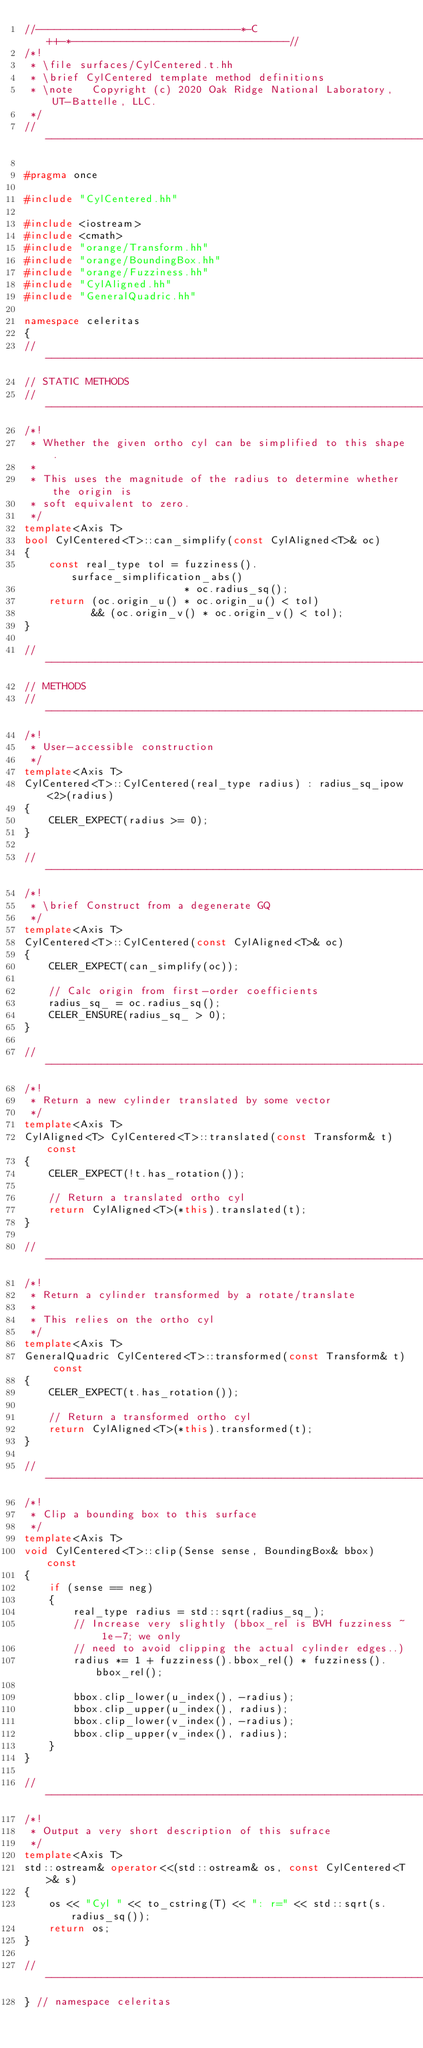<code> <loc_0><loc_0><loc_500><loc_500><_C++_>//---------------------------------*-C++-*-----------------------------------//
/*!
 * \file surfaces/CylCentered.t.hh
 * \brief CylCentered template method definitions
 * \note   Copyright (c) 2020 Oak Ridge National Laboratory, UT-Battelle, LLC.
 */
//---------------------------------------------------------------------------//

#pragma once

#include "CylCentered.hh"

#include <iostream>
#include <cmath>
#include "orange/Transform.hh"
#include "orange/BoundingBox.hh"
#include "orange/Fuzziness.hh"
#include "CylAligned.hh"
#include "GeneralQuadric.hh"

namespace celeritas
{
//---------------------------------------------------------------------------//
// STATIC METHODS
//---------------------------------------------------------------------------//
/*!
 * Whether the given ortho cyl can be simplified to this shape.
 *
 * This uses the magnitude of the radius to determine whether the origin is
 * soft equivalent to zero.
 */
template<Axis T>
bool CylCentered<T>::can_simplify(const CylAligned<T>& oc)
{
    const real_type tol = fuzziness().surface_simplification_abs()
                          * oc.radius_sq();
    return (oc.origin_u() * oc.origin_u() < tol)
           && (oc.origin_v() * oc.origin_v() < tol);
}

//---------------------------------------------------------------------------//
// METHODS
//---------------------------------------------------------------------------//
/*!
 * User-accessible construction
 */
template<Axis T>
CylCentered<T>::CylCentered(real_type radius) : radius_sq_ipow<2>(radius)
{
    CELER_EXPECT(radius >= 0);
}

//---------------------------------------------------------------------------//
/*!
 * \brief Construct from a degenerate GQ
 */
template<Axis T>
CylCentered<T>::CylCentered(const CylAligned<T>& oc)
{
    CELER_EXPECT(can_simplify(oc));

    // Calc origin from first-order coefficients
    radius_sq_ = oc.radius_sq();
    CELER_ENSURE(radius_sq_ > 0);
}

//---------------------------------------------------------------------------//
/*!
 * Return a new cylinder translated by some vector
 */
template<Axis T>
CylAligned<T> CylCentered<T>::translated(const Transform& t) const
{
    CELER_EXPECT(!t.has_rotation());

    // Return a translated ortho cyl
    return CylAligned<T>(*this).translated(t);
}

//---------------------------------------------------------------------------//
/*!
 * Return a cylinder transformed by a rotate/translate
 *
 * This relies on the ortho cyl
 */
template<Axis T>
GeneralQuadric CylCentered<T>::transformed(const Transform& t) const
{
    CELER_EXPECT(t.has_rotation());

    // Return a transformed ortho cyl
    return CylAligned<T>(*this).transformed(t);
}

//---------------------------------------------------------------------------//
/*!
 * Clip a bounding box to this surface
 */
template<Axis T>
void CylCentered<T>::clip(Sense sense, BoundingBox& bbox) const
{
    if (sense == neg)
    {
        real_type radius = std::sqrt(radius_sq_);
        // Increase very slightly (bbox_rel is BVH fuzziness ~ 1e-7; we only
        // need to avoid clipping the actual cylinder edges..)
        radius *= 1 + fuzziness().bbox_rel() * fuzziness().bbox_rel();

        bbox.clip_lower(u_index(), -radius);
        bbox.clip_upper(u_index(), radius);
        bbox.clip_lower(v_index(), -radius);
        bbox.clip_upper(v_index(), radius);
    }
}

//---------------------------------------------------------------------------//
/*!
 * Output a very short description of this sufrace
 */
template<Axis T>
std::ostream& operator<<(std::ostream& os, const CylCentered<T>& s)
{
    os << "Cyl " << to_cstring(T) << ": r=" << std::sqrt(s.radius_sq());
    return os;
}

//---------------------------------------------------------------------------//
} // namespace celeritas
</code> 